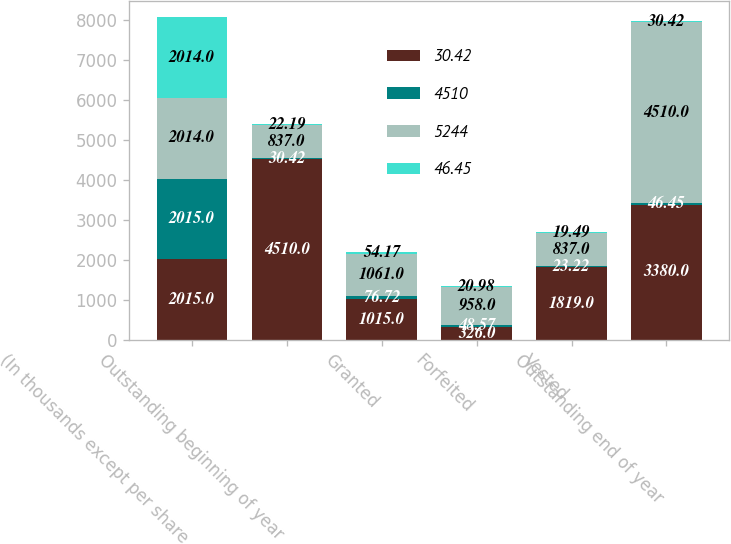Convert chart to OTSL. <chart><loc_0><loc_0><loc_500><loc_500><stacked_bar_chart><ecel><fcel>(In thousands except per share<fcel>Outstanding beginning of year<fcel>Granted<fcel>Forfeited<fcel>Vested<fcel>Outstanding end of year<nl><fcel>30.42<fcel>2015<fcel>4510<fcel>1015<fcel>326<fcel>1819<fcel>3380<nl><fcel>4510<fcel>2015<fcel>30.42<fcel>76.72<fcel>48.57<fcel>23.22<fcel>46.45<nl><fcel>5244<fcel>2014<fcel>837<fcel>1061<fcel>958<fcel>837<fcel>4510<nl><fcel>46.45<fcel>2014<fcel>22.19<fcel>54.17<fcel>20.98<fcel>19.49<fcel>30.42<nl></chart> 